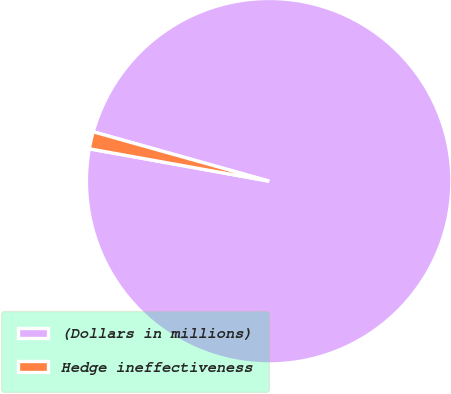Convert chart. <chart><loc_0><loc_0><loc_500><loc_500><pie_chart><fcel>(Dollars in millions)<fcel>Hedge ineffectiveness<nl><fcel>98.48%<fcel>1.52%<nl></chart> 